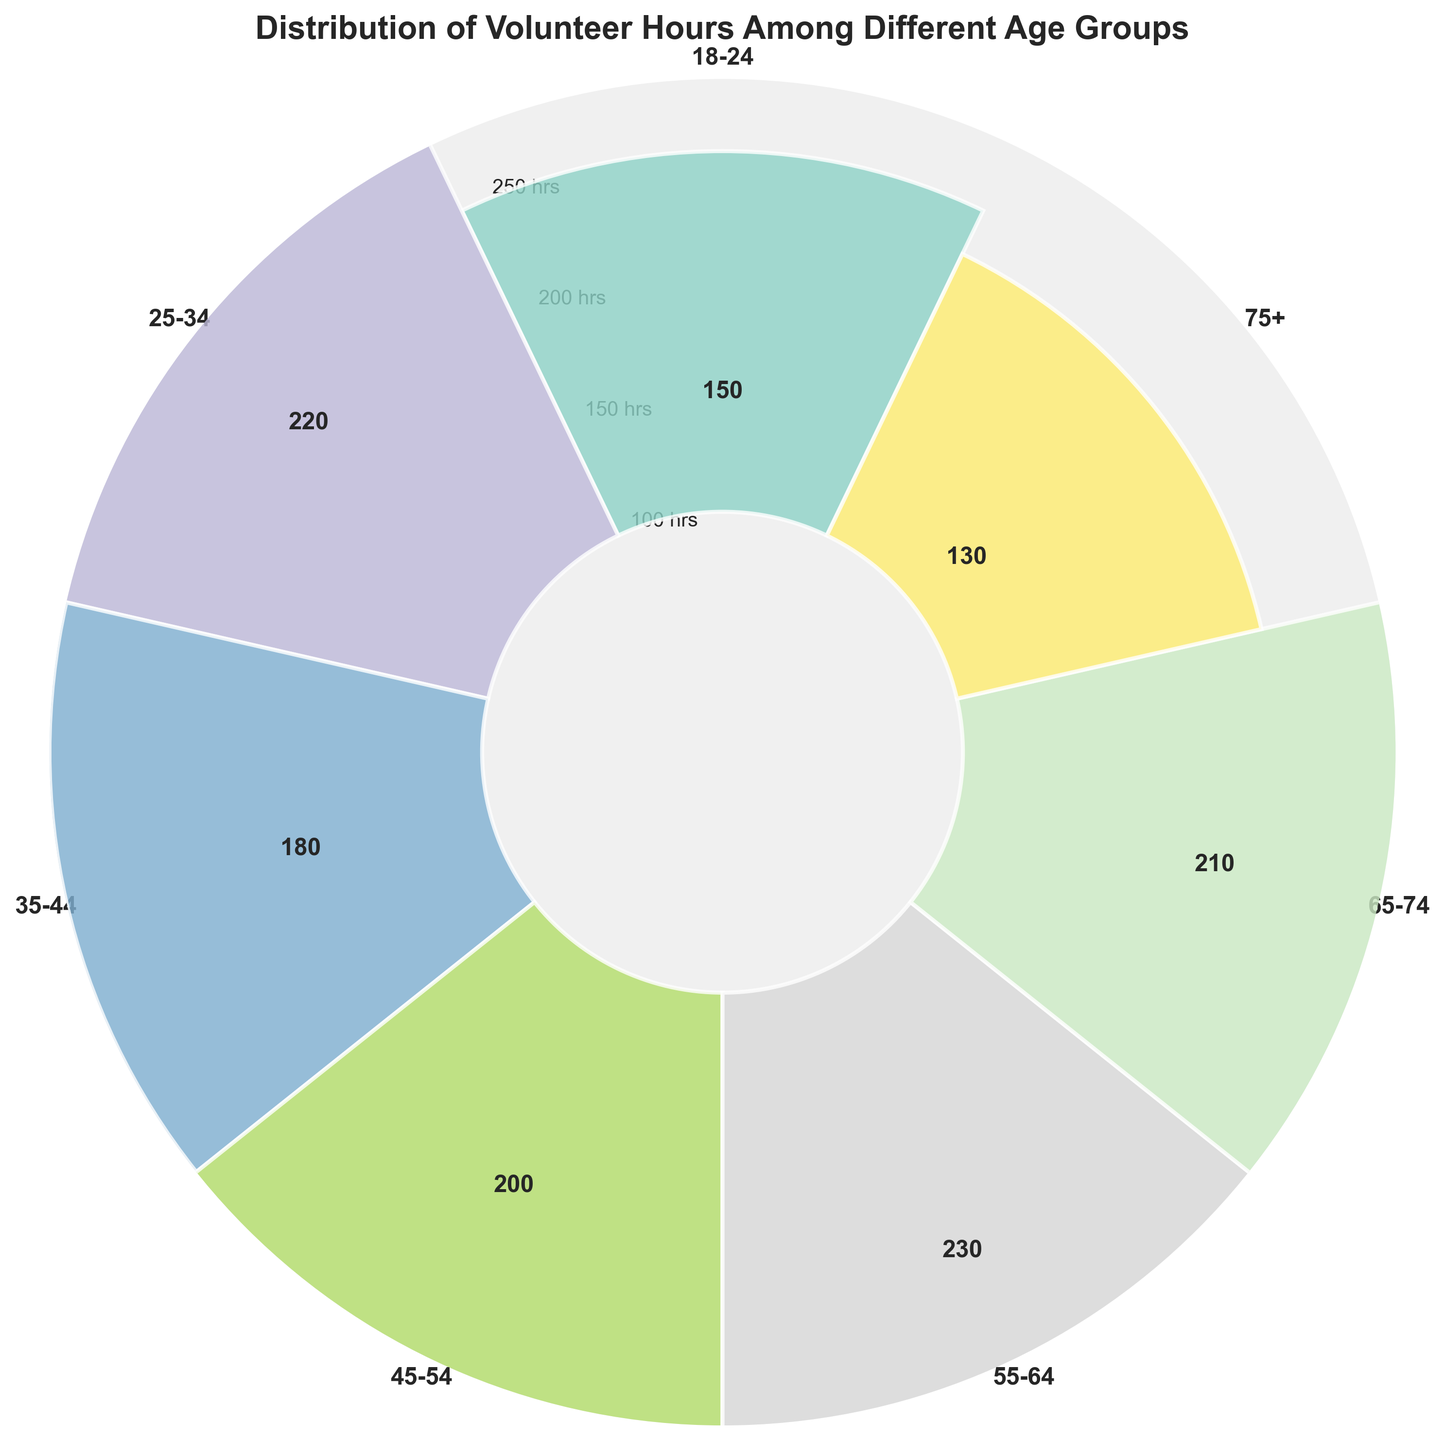What age group has the smallest number of volunteer hours? By observing the height of the bars in the figure, the bar with the lowest height represents the age group with the smallest number of volunteer hours. This corresponds to the 75+ age group.
Answer: 75+ What's the sum of the volunteer hours for the age groups 55-64 and 65-74? From the figure, the volunteer hours for the age group 55-64 are 230 and for the age group 65-74 are 210. Adding these together gives 230 + 210.
Answer: 440 Which age group has the highest number of volunteer hours? By comparing the heights of all the bars in the figure, the bar with the highest height represents the age group with the highest number of volunteer hours. This is the 55-64 age group.
Answer: 55-64 How many age groups have more than 200 volunteer hours? From the figure, the bars for the age groups 25-34, 55-64, and 65-74 are higher than the 200-hour mark. Counting these, we get three age groups.
Answer: 3 What is the average number of volunteer hours across all age groups? Adding the volunteer hours for all age groups: 150 (18-24) + 220 (25-34) + 180 (35-44) + 200 (45-54) + 230 (55-64) + 210 (65-74) + 130 (75+) and then dividing by 7 (total number of age groups): (150 + 220 + 180 + 200 + 230 + 210 + 130) / 7 = 1320 / 7.
Answer: 188.57 Are there more age groups with less than 200 volunteer hours or more than 200 volunteer hours? From the figure, the age groups with less than 200 volunteer hours are 18-24, 35-44, 45-54, and 75+. The age groups with more than 200 volunteer hours are 25-34, 55-64, and 65-74. Counting both, there are four age groups with less than 200 hours and three age groups with more than 200 hours.
Answer: Less than 200 What is the range of volunteer hours among the different age groups? The range is calculated by subtracting the smallest number of volunteer hours from the largest number. From the figure, the smallest is 130 (75+) and the largest is 230 (55-64). Therefore, the range is 230 - 130.
Answer: 100 How much more volunteer hours do the age group 25-34 have compared to the age group 75+? From the figure, the volunteer hours for 25-34 are 220 and for 75+ are 130. Subtracting these values gives 220 - 130.
Answer: 90 